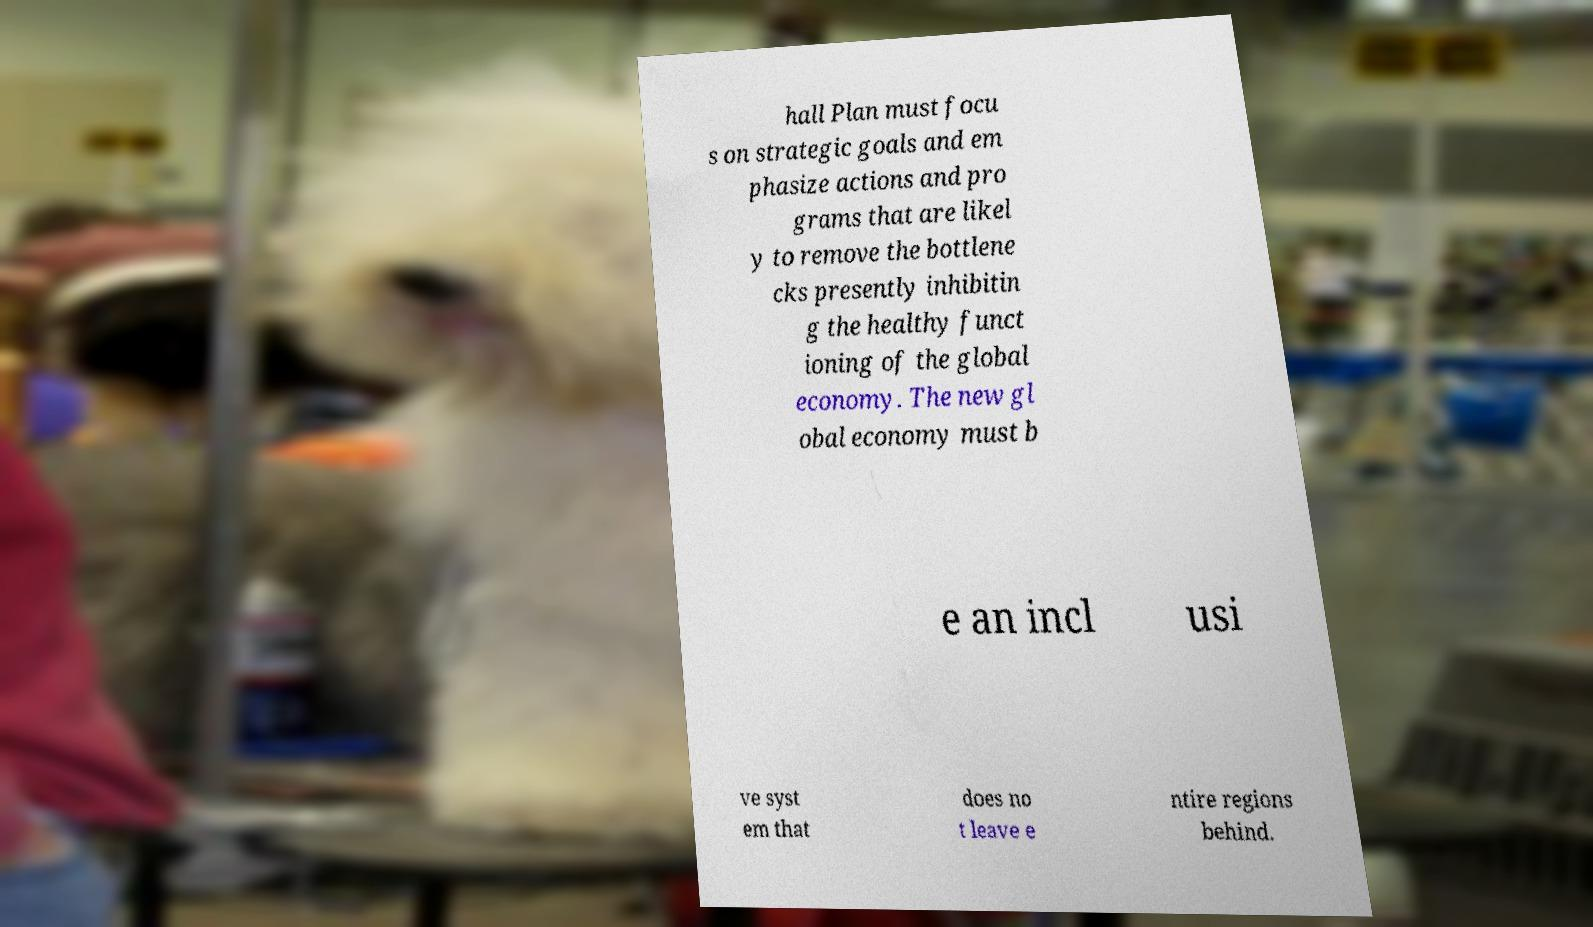For documentation purposes, I need the text within this image transcribed. Could you provide that? hall Plan must focu s on strategic goals and em phasize actions and pro grams that are likel y to remove the bottlene cks presently inhibitin g the healthy funct ioning of the global economy. The new gl obal economy must b e an incl usi ve syst em that does no t leave e ntire regions behind. 